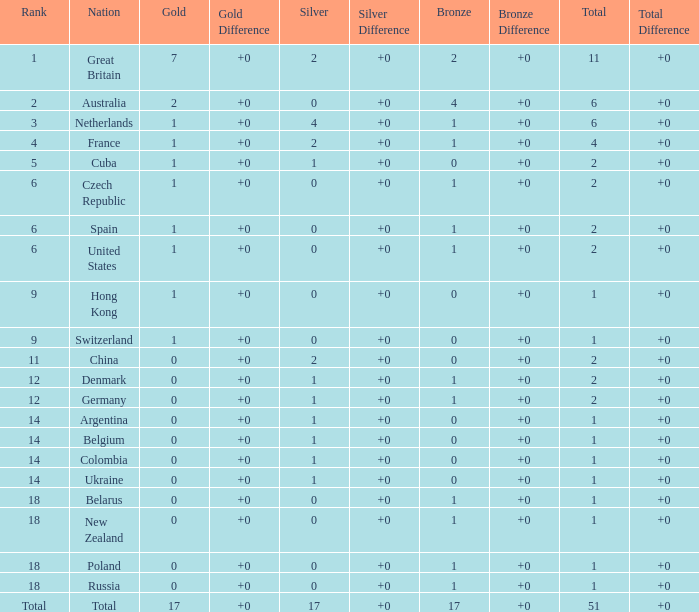Tell me the rank for bronze less than 17 and gold less than 1 11.0. 